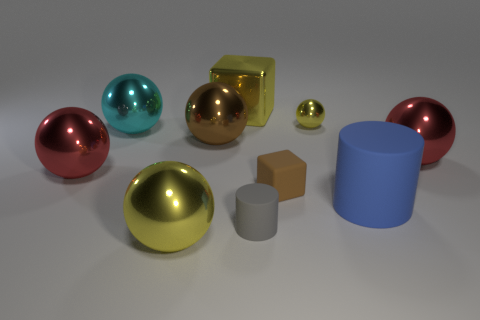There is a tiny shiny object; does it have the same color as the cube that is behind the brown metallic sphere?
Ensure brevity in your answer.  Yes. What is the shape of the big blue object?
Make the answer very short. Cylinder. Do the small sphere and the big cube have the same color?
Make the answer very short. Yes. What number of things are big objects to the right of the small brown matte cube or brown blocks?
Your answer should be very brief. 3. There is a brown object that is the same material as the large cyan thing; what size is it?
Make the answer very short. Large. Is the number of small matte objects that are behind the small gray object greater than the number of large cyan matte cylinders?
Your answer should be compact. Yes. Is the shape of the small shiny thing the same as the red shiny thing to the right of the brown shiny sphere?
Make the answer very short. Yes. What number of large things are either brown matte things or blue rubber objects?
Your answer should be very brief. 1. What is the color of the cube in front of the large cube to the right of the big yellow ball?
Keep it short and to the point. Brown. Is the large blue object made of the same material as the yellow sphere on the right side of the rubber cube?
Offer a very short reply. No. 